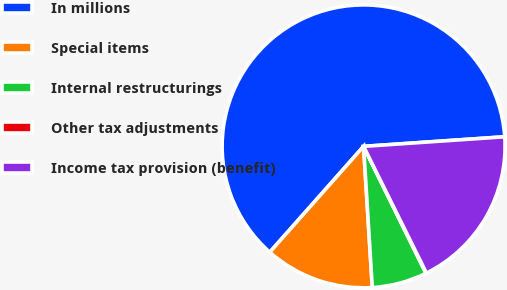<chart> <loc_0><loc_0><loc_500><loc_500><pie_chart><fcel>In millions<fcel>Special items<fcel>Internal restructurings<fcel>Other tax adjustments<fcel>Income tax provision (benefit)<nl><fcel>62.37%<fcel>12.52%<fcel>6.29%<fcel>0.06%<fcel>18.75%<nl></chart> 